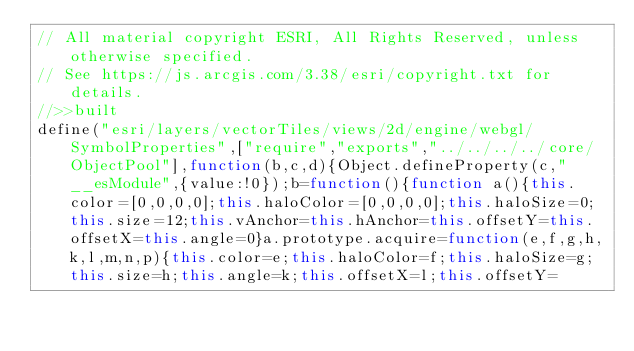<code> <loc_0><loc_0><loc_500><loc_500><_JavaScript_>// All material copyright ESRI, All Rights Reserved, unless otherwise specified.
// See https://js.arcgis.com/3.38/esri/copyright.txt for details.
//>>built
define("esri/layers/vectorTiles/views/2d/engine/webgl/SymbolProperties",["require","exports","../../../../core/ObjectPool"],function(b,c,d){Object.defineProperty(c,"__esModule",{value:!0});b=function(){function a(){this.color=[0,0,0,0];this.haloColor=[0,0,0,0];this.haloSize=0;this.size=12;this.vAnchor=this.hAnchor=this.offsetY=this.offsetX=this.angle=0}a.prototype.acquire=function(e,f,g,h,k,l,m,n,p){this.color=e;this.haloColor=f;this.haloSize=g;this.size=h;this.angle=k;this.offsetX=l;this.offsetY=</code> 